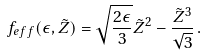Convert formula to latex. <formula><loc_0><loc_0><loc_500><loc_500>f _ { e f f } ( \epsilon , \tilde { Z } ) = \sqrt { \frac { 2 \epsilon } { 3 } } \tilde { Z } ^ { 2 } - \frac { \tilde { Z } ^ { 3 } } { \sqrt { 3 } } \, .</formula> 